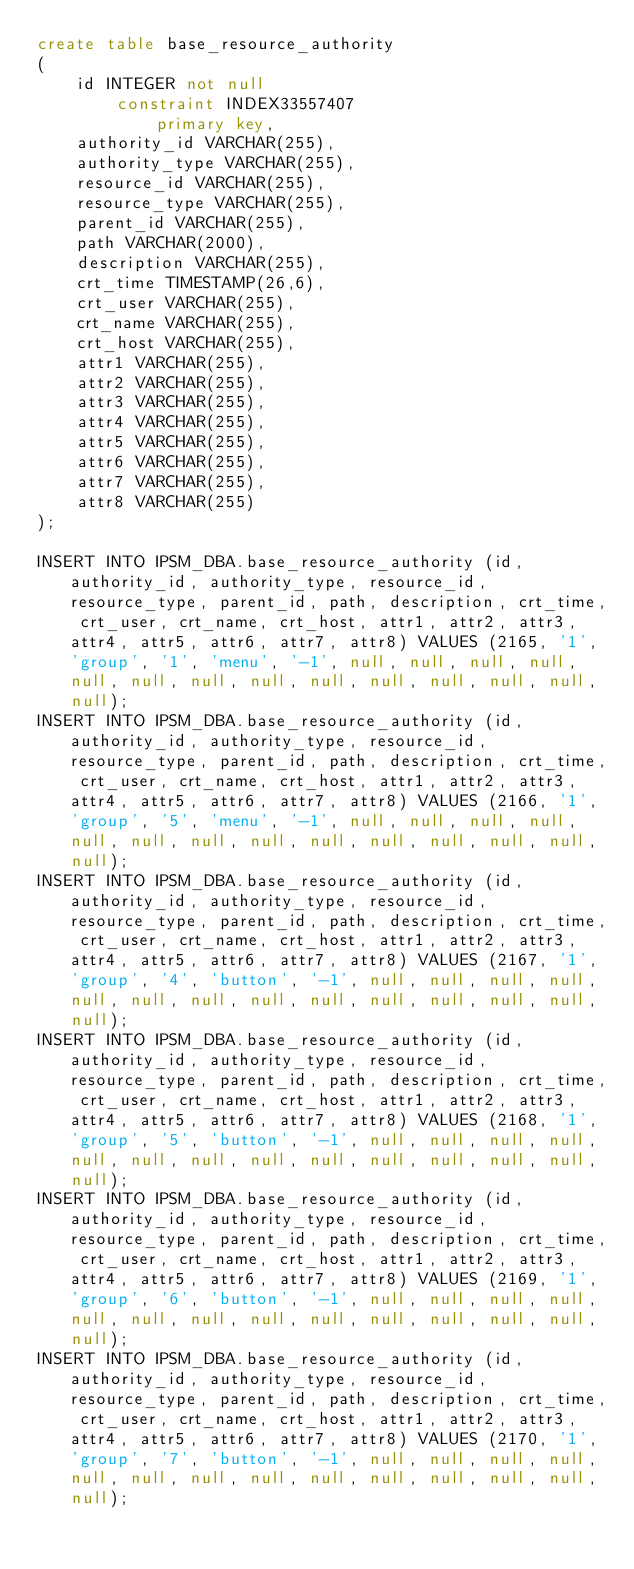Convert code to text. <code><loc_0><loc_0><loc_500><loc_500><_SQL_>create table base_resource_authority
(
	id INTEGER not null
		constraint INDEX33557407
			primary key,
	authority_id VARCHAR(255),
	authority_type VARCHAR(255),
	resource_id VARCHAR(255),
	resource_type VARCHAR(255),
	parent_id VARCHAR(255),
	path VARCHAR(2000),
	description VARCHAR(255),
	crt_time TIMESTAMP(26,6),
	crt_user VARCHAR(255),
	crt_name VARCHAR(255),
	crt_host VARCHAR(255),
	attr1 VARCHAR(255),
	attr2 VARCHAR(255),
	attr3 VARCHAR(255),
	attr4 VARCHAR(255),
	attr5 VARCHAR(255),
	attr6 VARCHAR(255),
	attr7 VARCHAR(255),
	attr8 VARCHAR(255)
);

INSERT INTO IPSM_DBA.base_resource_authority (id, authority_id, authority_type, resource_id, resource_type, parent_id, path, description, crt_time, crt_user, crt_name, crt_host, attr1, attr2, attr3, attr4, attr5, attr6, attr7, attr8) VALUES (2165, '1', 'group', '1', 'menu', '-1', null, null, null, null, null, null, null, null, null, null, null, null, null, null);
INSERT INTO IPSM_DBA.base_resource_authority (id, authority_id, authority_type, resource_id, resource_type, parent_id, path, description, crt_time, crt_user, crt_name, crt_host, attr1, attr2, attr3, attr4, attr5, attr6, attr7, attr8) VALUES (2166, '1', 'group', '5', 'menu', '-1', null, null, null, null, null, null, null, null, null, null, null, null, null, null);
INSERT INTO IPSM_DBA.base_resource_authority (id, authority_id, authority_type, resource_id, resource_type, parent_id, path, description, crt_time, crt_user, crt_name, crt_host, attr1, attr2, attr3, attr4, attr5, attr6, attr7, attr8) VALUES (2167, '1', 'group', '4', 'button', '-1', null, null, null, null, null, null, null, null, null, null, null, null, null, null);
INSERT INTO IPSM_DBA.base_resource_authority (id, authority_id, authority_type, resource_id, resource_type, parent_id, path, description, crt_time, crt_user, crt_name, crt_host, attr1, attr2, attr3, attr4, attr5, attr6, attr7, attr8) VALUES (2168, '1', 'group', '5', 'button', '-1', null, null, null, null, null, null, null, null, null, null, null, null, null, null);
INSERT INTO IPSM_DBA.base_resource_authority (id, authority_id, authority_type, resource_id, resource_type, parent_id, path, description, crt_time, crt_user, crt_name, crt_host, attr1, attr2, attr3, attr4, attr5, attr6, attr7, attr8) VALUES (2169, '1', 'group', '6', 'button', '-1', null, null, null, null, null, null, null, null, null, null, null, null, null, null);
INSERT INTO IPSM_DBA.base_resource_authority (id, authority_id, authority_type, resource_id, resource_type, parent_id, path, description, crt_time, crt_user, crt_name, crt_host, attr1, attr2, attr3, attr4, attr5, attr6, attr7, attr8) VALUES (2170, '1', 'group', '7', 'button', '-1', null, null, null, null, null, null, null, null, null, null, null, null, null, null);</code> 